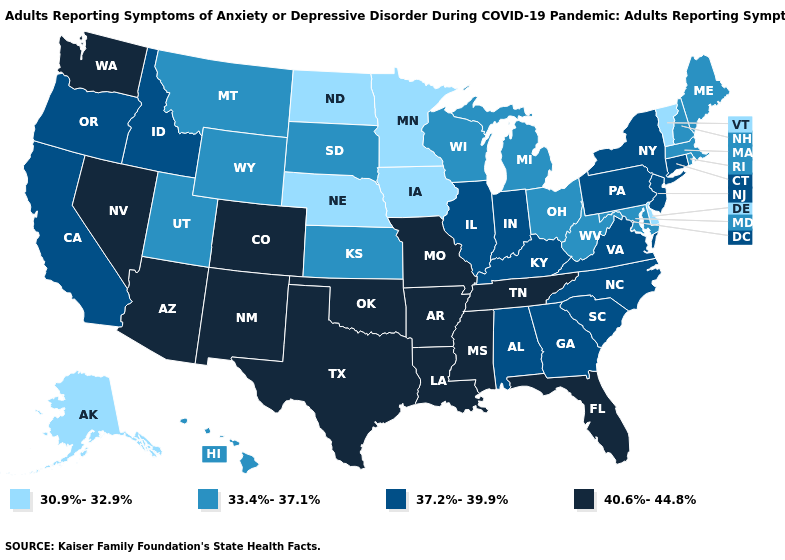Does Hawaii have the same value as Wisconsin?
Give a very brief answer. Yes. Does Iowa have the lowest value in the USA?
Quick response, please. Yes. Name the states that have a value in the range 30.9%-32.9%?
Concise answer only. Alaska, Delaware, Iowa, Minnesota, Nebraska, North Dakota, Vermont. Name the states that have a value in the range 37.2%-39.9%?
Answer briefly. Alabama, California, Connecticut, Georgia, Idaho, Illinois, Indiana, Kentucky, New Jersey, New York, North Carolina, Oregon, Pennsylvania, South Carolina, Virginia. What is the lowest value in states that border Rhode Island?
Keep it brief. 33.4%-37.1%. Which states hav the highest value in the South?
Give a very brief answer. Arkansas, Florida, Louisiana, Mississippi, Oklahoma, Tennessee, Texas. Among the states that border Missouri , does Iowa have the lowest value?
Answer briefly. Yes. Does the map have missing data?
Write a very short answer. No. What is the value of Washington?
Short answer required. 40.6%-44.8%. Does Alaska have the lowest value in the USA?
Concise answer only. Yes. What is the lowest value in the Northeast?
Short answer required. 30.9%-32.9%. What is the value of Nebraska?
Short answer required. 30.9%-32.9%. What is the highest value in states that border Idaho?
Short answer required. 40.6%-44.8%. What is the value of Alaska?
Keep it brief. 30.9%-32.9%. Among the states that border Kansas , does Nebraska have the highest value?
Quick response, please. No. 